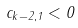<formula> <loc_0><loc_0><loc_500><loc_500>c _ { k - 2 , 1 } < 0</formula> 